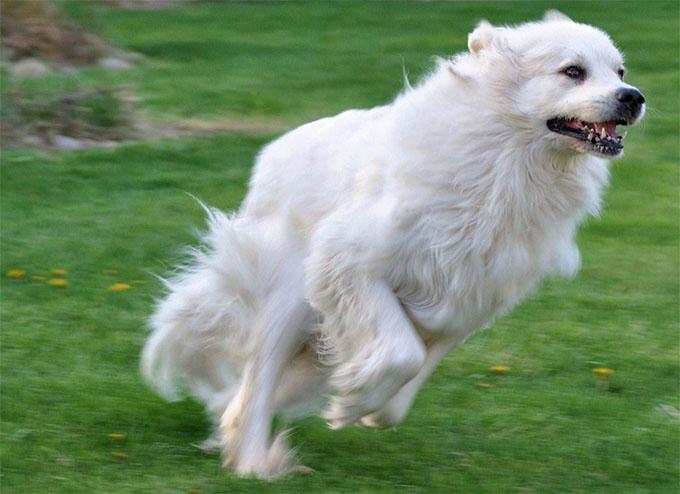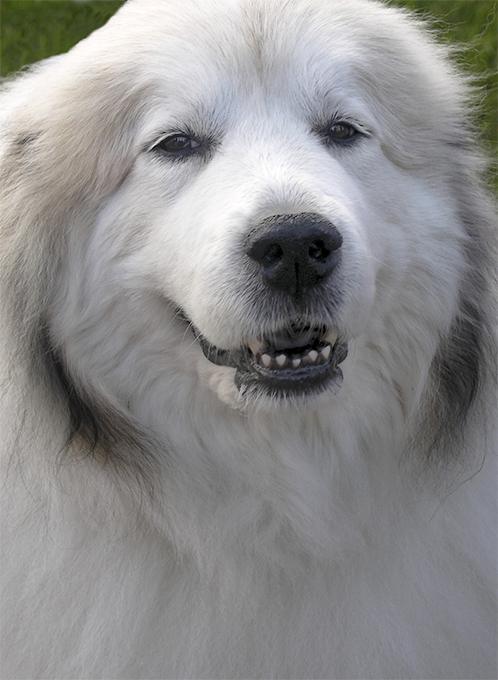The first image is the image on the left, the second image is the image on the right. Examine the images to the left and right. Is the description "There is at least one dog not in the grass" accurate? Answer yes or no. No. The first image is the image on the left, the second image is the image on the right. Given the left and right images, does the statement "In one image there is a white dog outside in the grass." hold true? Answer yes or no. Yes. The first image is the image on the left, the second image is the image on the right. Given the left and right images, does the statement "A full sized dog is sitting with its legs extended on the ground" hold true? Answer yes or no. No. 